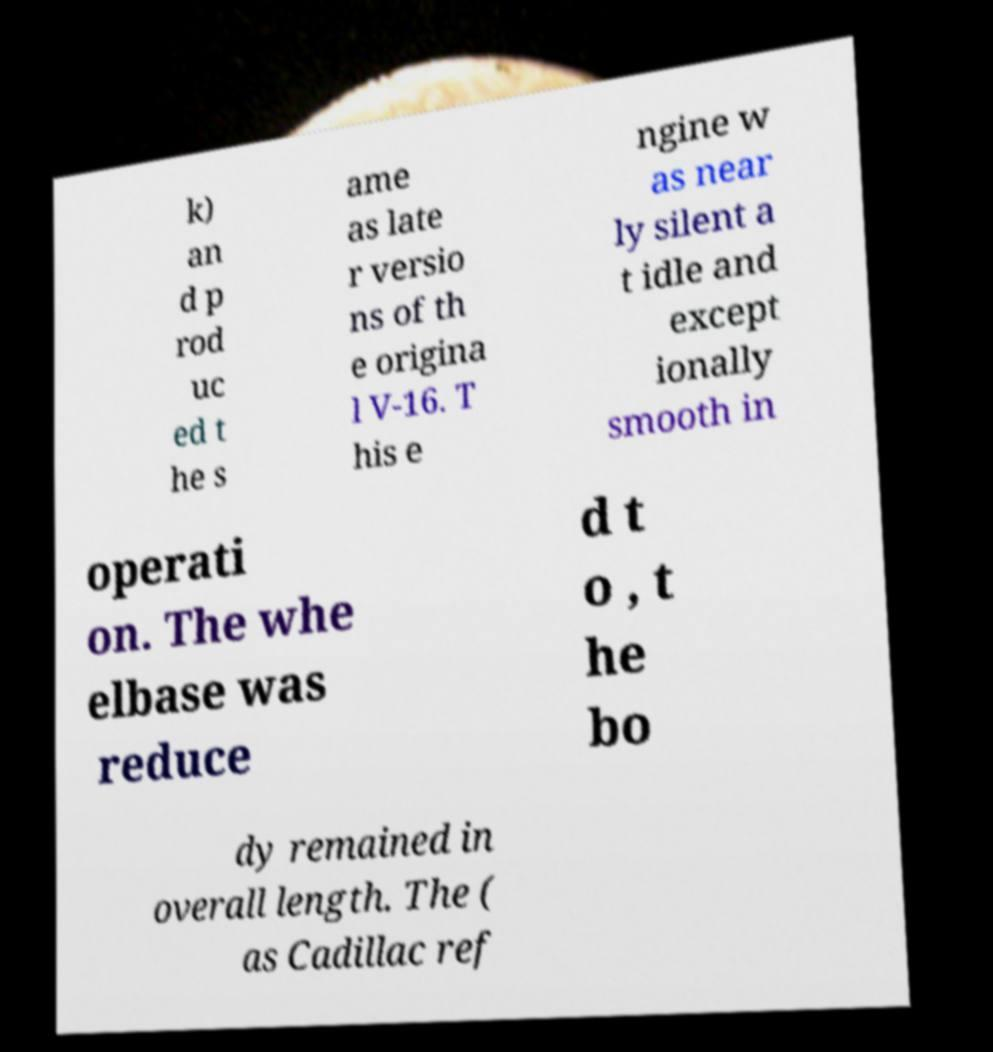Please read and relay the text visible in this image. What does it say? k) an d p rod uc ed t he s ame as late r versio ns of th e origina l V-16. T his e ngine w as near ly silent a t idle and except ionally smooth in operati on. The whe elbase was reduce d t o , t he bo dy remained in overall length. The ( as Cadillac ref 